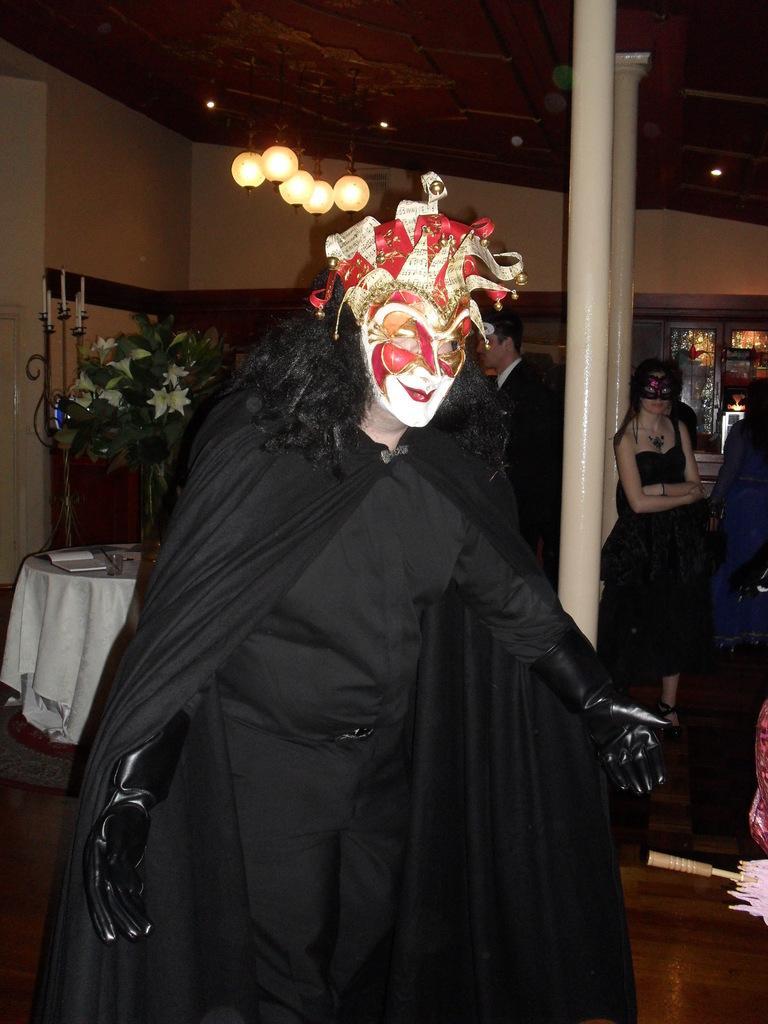Can you describe this image briefly? In this picture we can see the woman wearing a black costume and white mask, standing in the front. Behind we can see a woman wearing a black top and eye mask, standing and looking at the camera. Behind there is a wooden wardrobe and plant pot. On the top we can see the hanging lights on the ceiling roof. 